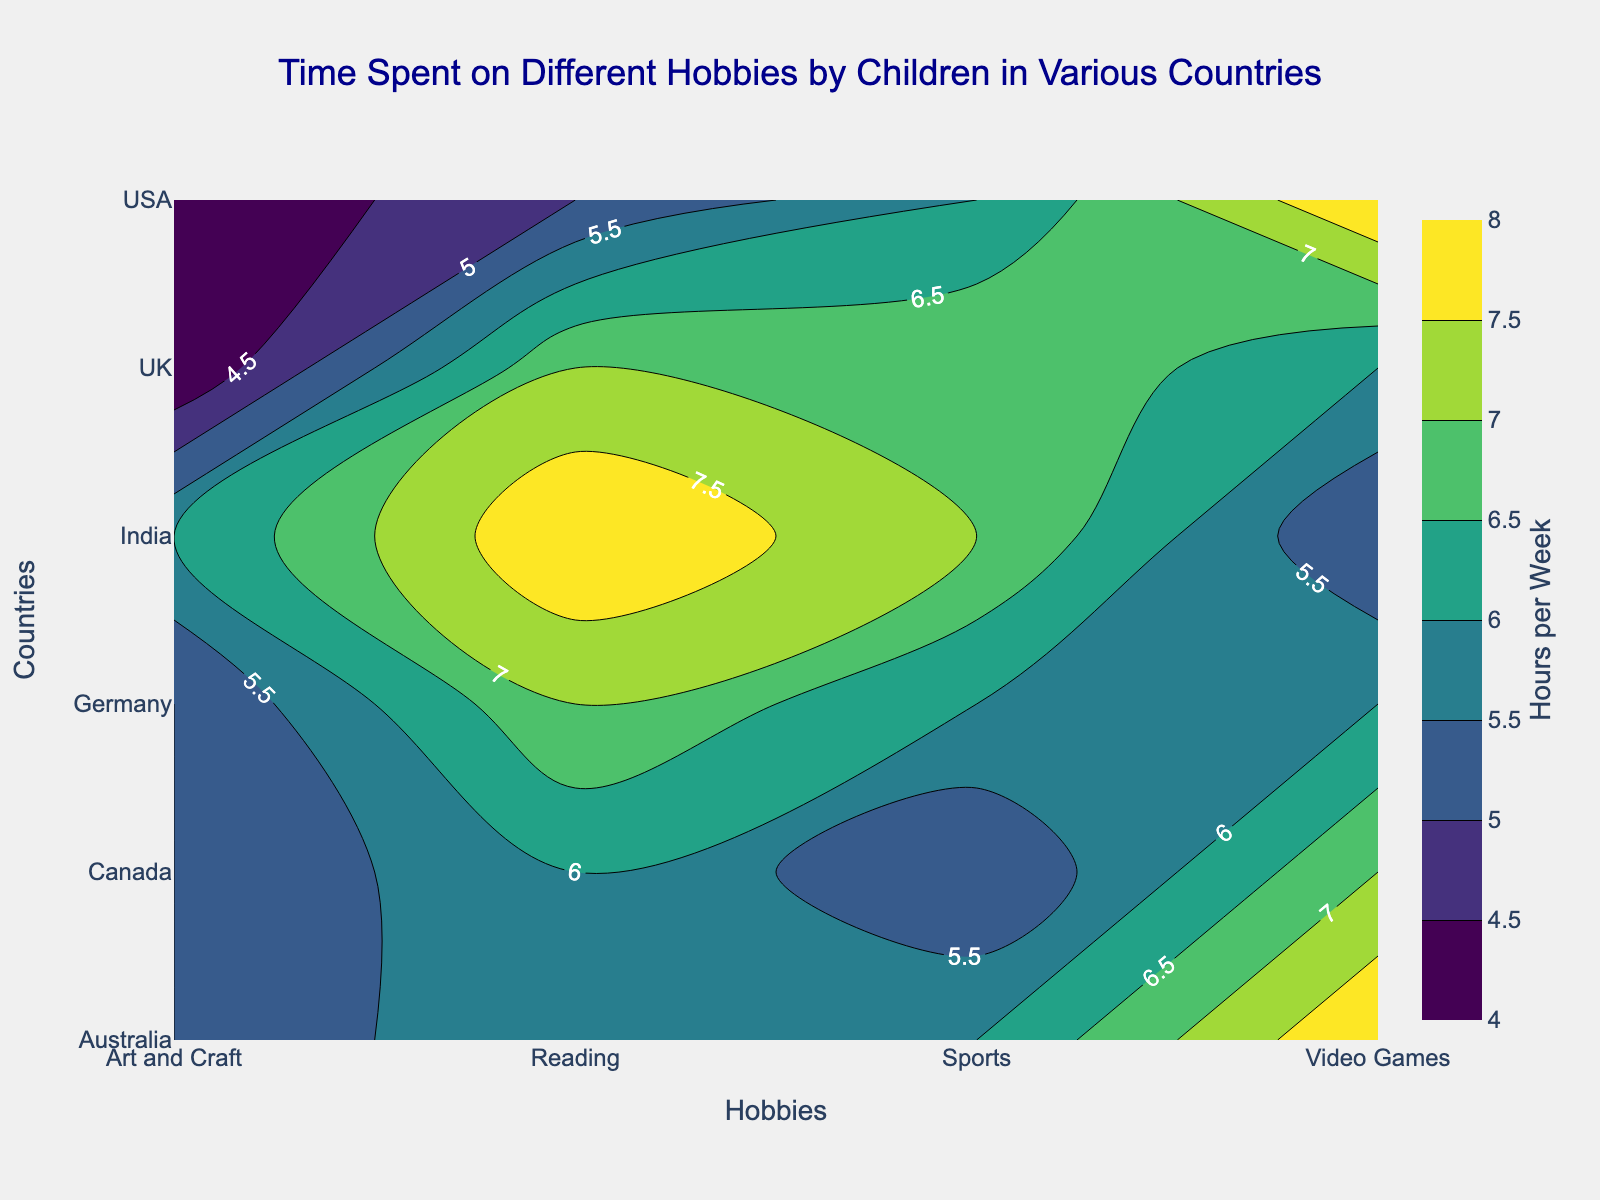What's the title of the plot? The title of the plot is written at the top of the figure in large, dark blue font.
Answer: Time Spent on Different Hobbies by Children in Various Countries Which country spends the most time on reading? From the contour plot, locate the highest contour label under the "Reading" hobby. It shows that India spends the most time on reading.
Answer: India Which hobby do children in the USA spend the least time on? By examining the contour values for the USA across all hobbies, the lowest number is found under "Art and Craft".
Answer: Art and Craft What's the average time spent by children on Video Games in all listed countries? Add the hours spent on Video Games in each country and divide by the number of countries (8+7+6+8+5+6). The sum is 40, and there are 6 countries, so the average is 40/6.
Answer: 6.67 Compare the hours spent on Sports by children in the UK and Germany. Which one is higher and by how much? Find the contour labels for Sports for both the UK and Germany. The UK is 7 hours, and Germany is 6 hours. The difference is 7 - 6.
Answer: UK; 1 hour Which hobby has the highest average time spent across all countries? Calculate the average time for each hobby: (Reading=5+6+7+6+8+7)/6, (Video Games=8+7+6+8+5+6)/6, (Sports=6+5+7+6+7+6)/6, (Art and Craft=4+5+4+5+6+5)/6. Reading has the highest average of (39/6).
Answer: Reading Which two countries have the most similar time spent on Art and Craft? Check the hours spent on Art and Craft for each country. USA and Canada, and Germany and Australia both spend 4 and 5 hours respectively, but Germany and Australia have identical hours.
Answer: Germany and Australia How much more time do children in India spend on Reading compared to Video Games? Look at the values for Reading and Video Games for India. Reading = 8 hours, Video Games = 5 hours. The difference is 8 - 5.
Answer: 3 hours What is the color of the contour representing 8 hours per week? The color representation can be inferred from the color scale. Since the Viridis color scale is used, 8 hours would be closer to the brighter yellow color.
Answer: Bright yellow 